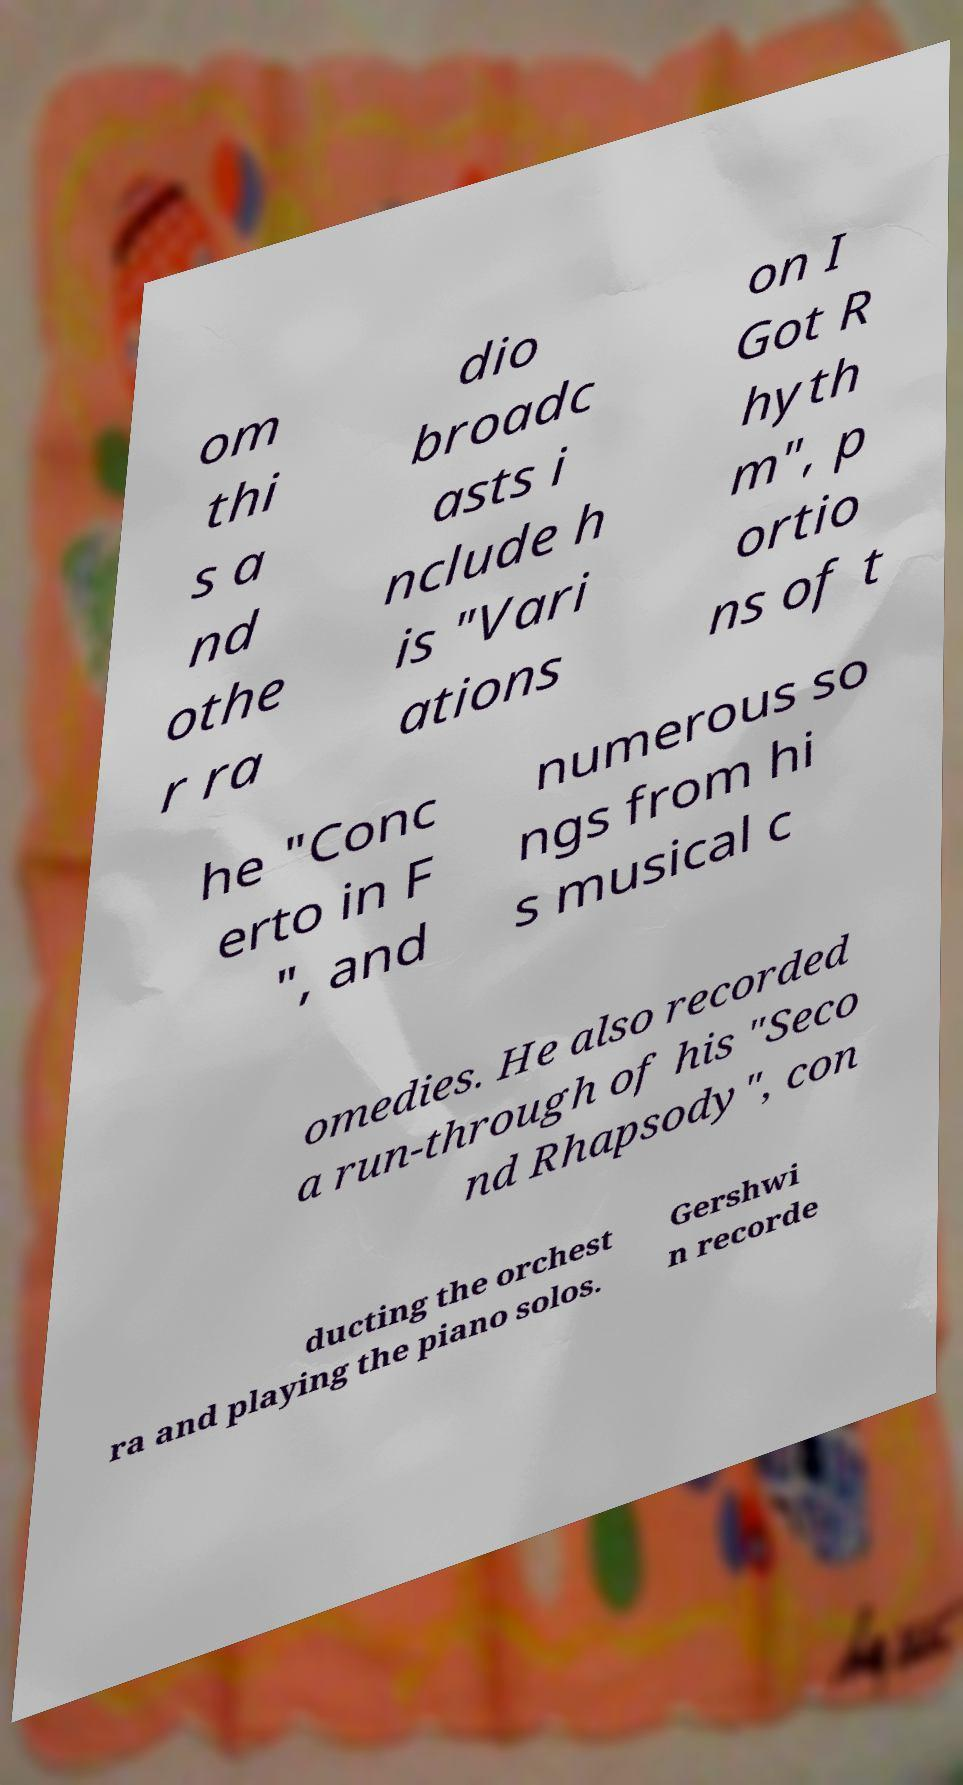I need the written content from this picture converted into text. Can you do that? om thi s a nd othe r ra dio broadc asts i nclude h is "Vari ations on I Got R hyth m", p ortio ns of t he "Conc erto in F ", and numerous so ngs from hi s musical c omedies. He also recorded a run-through of his "Seco nd Rhapsody", con ducting the orchest ra and playing the piano solos. Gershwi n recorde 